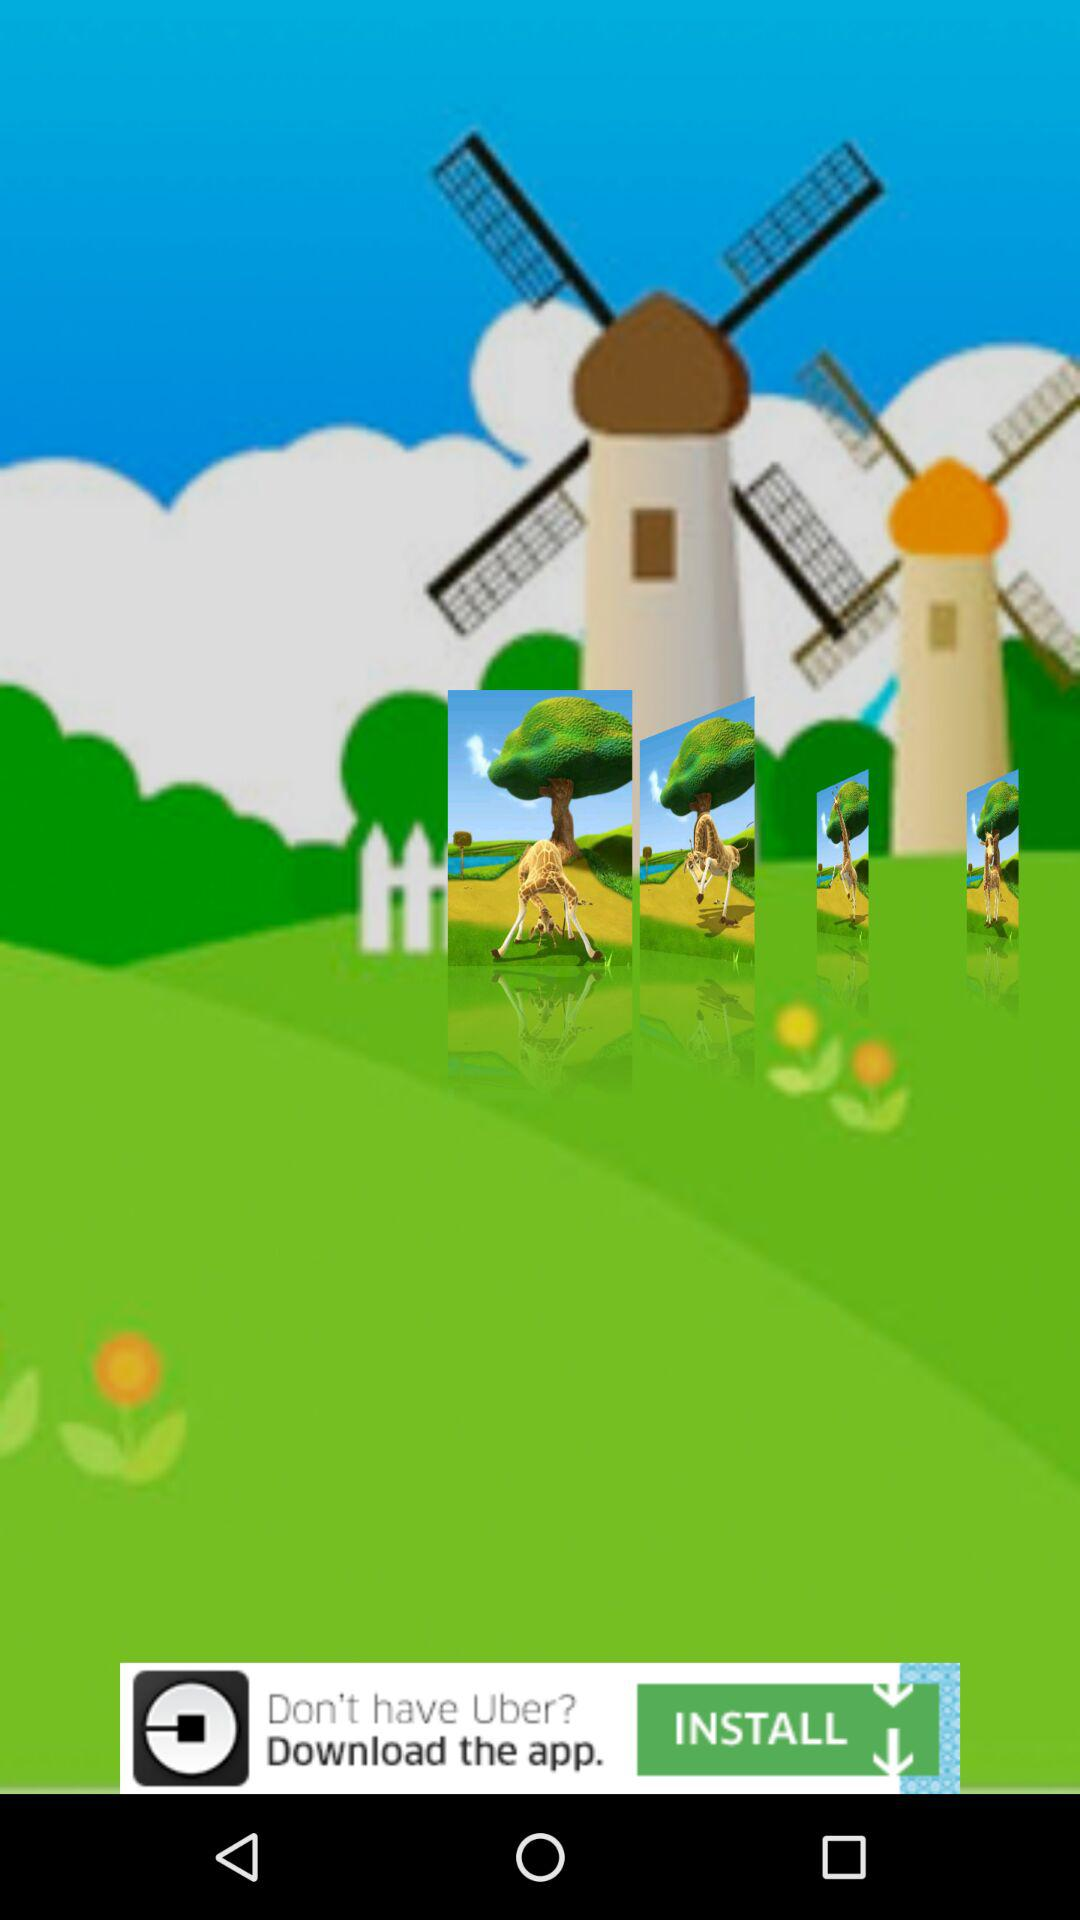How many giraffes are in the field?
Answer the question using a single word or phrase. 4 